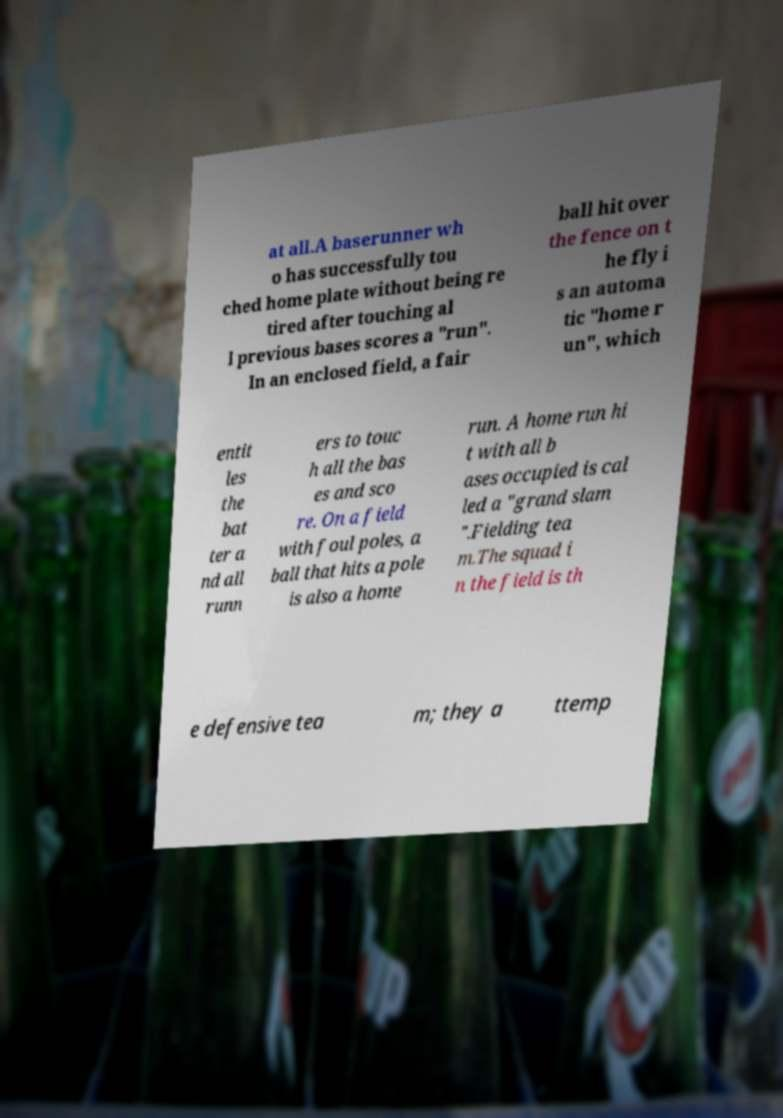For documentation purposes, I need the text within this image transcribed. Could you provide that? at all.A baserunner wh o has successfully tou ched home plate without being re tired after touching al l previous bases scores a "run". In an enclosed field, a fair ball hit over the fence on t he fly i s an automa tic "home r un", which entit les the bat ter a nd all runn ers to touc h all the bas es and sco re. On a field with foul poles, a ball that hits a pole is also a home run. A home run hi t with all b ases occupied is cal led a "grand slam ".Fielding tea m.The squad i n the field is th e defensive tea m; they a ttemp 